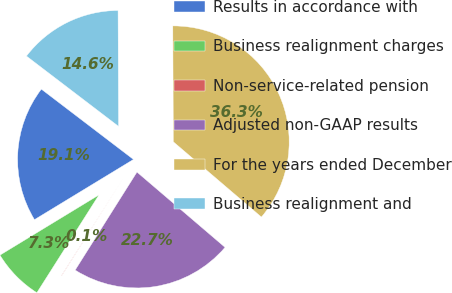<chart> <loc_0><loc_0><loc_500><loc_500><pie_chart><fcel>Results in accordance with<fcel>Business realignment charges<fcel>Non-service-related pension<fcel>Adjusted non-GAAP results<fcel>For the years ended December<fcel>Business realignment and<nl><fcel>19.07%<fcel>7.3%<fcel>0.05%<fcel>22.7%<fcel>36.32%<fcel>14.56%<nl></chart> 